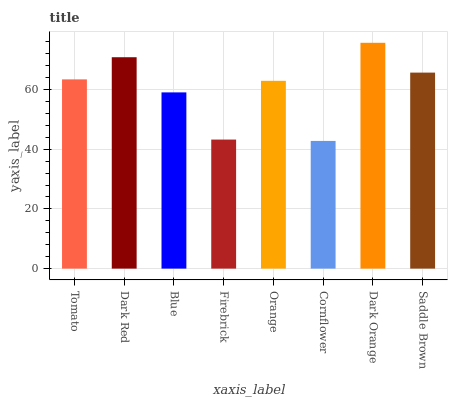Is Dark Red the minimum?
Answer yes or no. No. Is Dark Red the maximum?
Answer yes or no. No. Is Dark Red greater than Tomato?
Answer yes or no. Yes. Is Tomato less than Dark Red?
Answer yes or no. Yes. Is Tomato greater than Dark Red?
Answer yes or no. No. Is Dark Red less than Tomato?
Answer yes or no. No. Is Tomato the high median?
Answer yes or no. Yes. Is Orange the low median?
Answer yes or no. Yes. Is Dark Orange the high median?
Answer yes or no. No. Is Cornflower the low median?
Answer yes or no. No. 